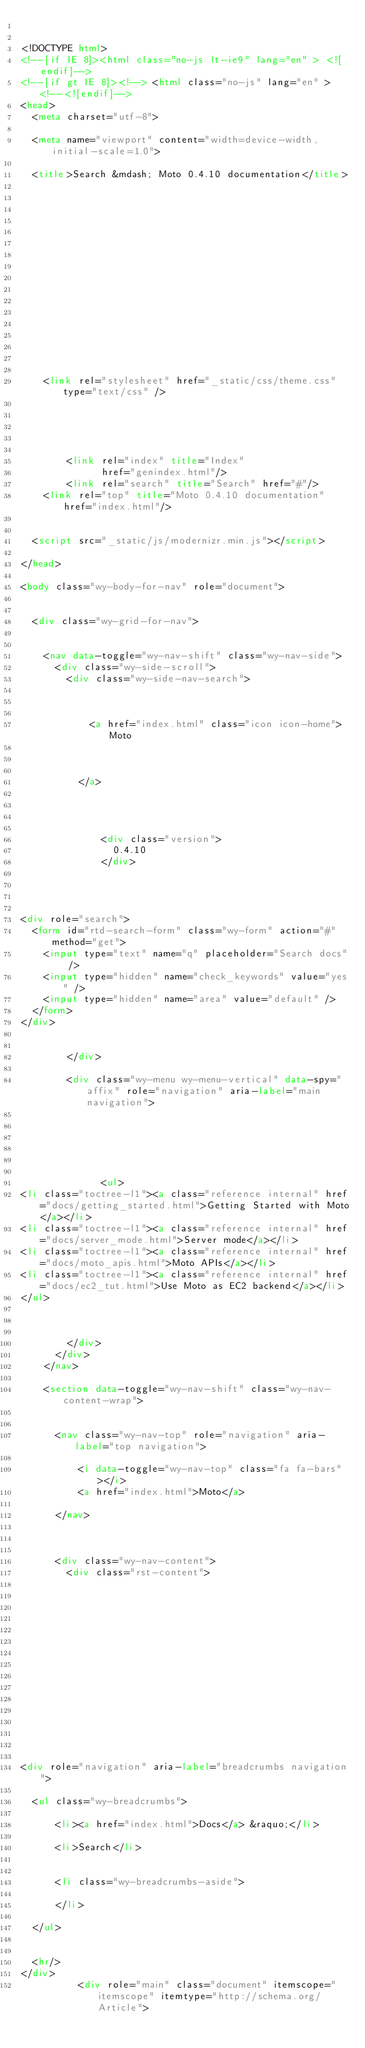<code> <loc_0><loc_0><loc_500><loc_500><_HTML_>

<!DOCTYPE html>
<!--[if IE 8]><html class="no-js lt-ie9" lang="en" > <![endif]-->
<!--[if gt IE 8]><!--> <html class="no-js" lang="en" > <!--<![endif]-->
<head>
  <meta charset="utf-8">
  
  <meta name="viewport" content="width=device-width, initial-scale=1.0">
  
  <title>Search &mdash; Moto 0.4.10 documentation</title>
  

  
  
  
  

  

  
  
    

  

  
  
    <link rel="stylesheet" href="_static/css/theme.css" type="text/css" />
  

  

  
        <link rel="index" title="Index"
              href="genindex.html"/>
        <link rel="search" title="Search" href="#"/>
    <link rel="top" title="Moto 0.4.10 documentation" href="index.html"/> 

  
  <script src="_static/js/modernizr.min.js"></script>

</head>

<body class="wy-body-for-nav" role="document">

   
  <div class="wy-grid-for-nav">

    
    <nav data-toggle="wy-nav-shift" class="wy-nav-side">
      <div class="wy-side-scroll">
        <div class="wy-side-nav-search">
          

          
            <a href="index.html" class="icon icon-home"> Moto
          

          
          </a>

          
            
            
              <div class="version">
                0.4.10
              </div>
            
          

          
<div role="search">
  <form id="rtd-search-form" class="wy-form" action="#" method="get">
    <input type="text" name="q" placeholder="Search docs" />
    <input type="hidden" name="check_keywords" value="yes" />
    <input type="hidden" name="area" value="default" />
  </form>
</div>

          
        </div>

        <div class="wy-menu wy-menu-vertical" data-spy="affix" role="navigation" aria-label="main navigation">
          
            
            
              
            
            
              <ul>
<li class="toctree-l1"><a class="reference internal" href="docs/getting_started.html">Getting Started with Moto</a></li>
<li class="toctree-l1"><a class="reference internal" href="docs/server_mode.html">Server mode</a></li>
<li class="toctree-l1"><a class="reference internal" href="docs/moto_apis.html">Moto APIs</a></li>
<li class="toctree-l1"><a class="reference internal" href="docs/ec2_tut.html">Use Moto as EC2 backend</a></li>
</ul>

            
          
        </div>
      </div>
    </nav>

    <section data-toggle="wy-nav-shift" class="wy-nav-content-wrap">

      
      <nav class="wy-nav-top" role="navigation" aria-label="top navigation">
        
          <i data-toggle="wy-nav-top" class="fa fa-bars"></i>
          <a href="index.html">Moto</a>
        
      </nav>


      
      <div class="wy-nav-content">
        <div class="rst-content">
          















<div role="navigation" aria-label="breadcrumbs navigation">

  <ul class="wy-breadcrumbs">
    
      <li><a href="index.html">Docs</a> &raquo;</li>
        
      <li>Search</li>
    
    
      <li class="wy-breadcrumbs-aside">
        
      </li>
    
  </ul>

  
  <hr/>
</div>
          <div role="main" class="document" itemscope="itemscope" itemtype="http://schema.org/Article"></code> 